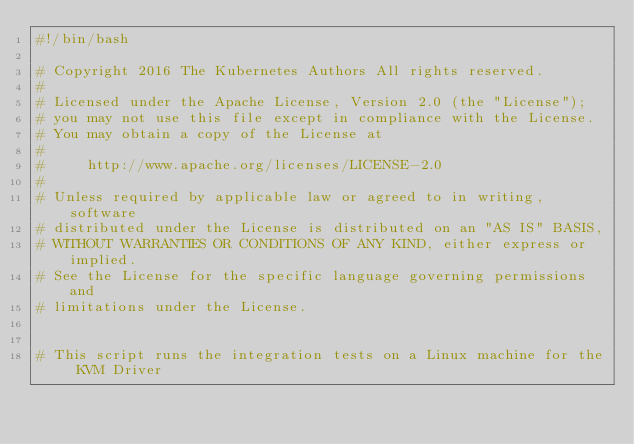Convert code to text. <code><loc_0><loc_0><loc_500><loc_500><_Bash_>#!/bin/bash

# Copyright 2016 The Kubernetes Authors All rights reserved.
#
# Licensed under the Apache License, Version 2.0 (the "License");
# you may not use this file except in compliance with the License.
# You may obtain a copy of the License at
#
#     http://www.apache.org/licenses/LICENSE-2.0
#
# Unless required by applicable law or agreed to in writing, software
# distributed under the License is distributed on an "AS IS" BASIS,
# WITHOUT WARRANTIES OR CONDITIONS OF ANY KIND, either express or implied.
# See the License for the specific language governing permissions and
# limitations under the License.


# This script runs the integration tests on a Linux machine for the KVM Driver
</code> 